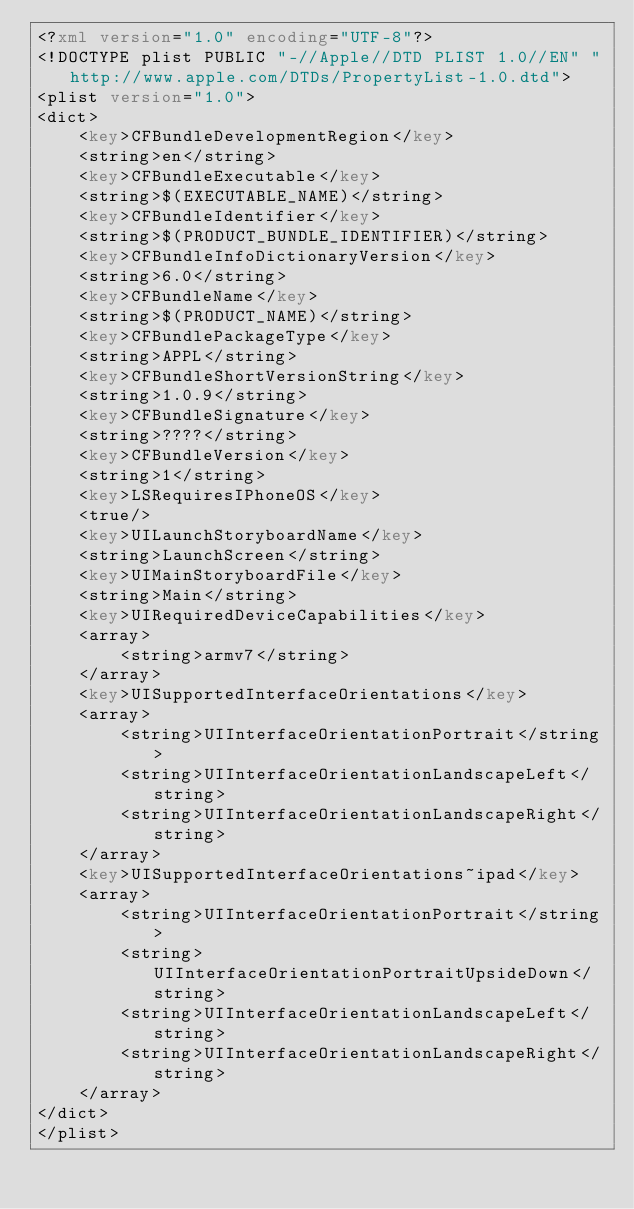Convert code to text. <code><loc_0><loc_0><loc_500><loc_500><_XML_><?xml version="1.0" encoding="UTF-8"?>
<!DOCTYPE plist PUBLIC "-//Apple//DTD PLIST 1.0//EN" "http://www.apple.com/DTDs/PropertyList-1.0.dtd">
<plist version="1.0">
<dict>
	<key>CFBundleDevelopmentRegion</key>
	<string>en</string>
	<key>CFBundleExecutable</key>
	<string>$(EXECUTABLE_NAME)</string>
	<key>CFBundleIdentifier</key>
	<string>$(PRODUCT_BUNDLE_IDENTIFIER)</string>
	<key>CFBundleInfoDictionaryVersion</key>
	<string>6.0</string>
	<key>CFBundleName</key>
	<string>$(PRODUCT_NAME)</string>
	<key>CFBundlePackageType</key>
	<string>APPL</string>
	<key>CFBundleShortVersionString</key>
	<string>1.0.9</string>
	<key>CFBundleSignature</key>
	<string>????</string>
	<key>CFBundleVersion</key>
	<string>1</string>
	<key>LSRequiresIPhoneOS</key>
	<true/>
	<key>UILaunchStoryboardName</key>
	<string>LaunchScreen</string>
	<key>UIMainStoryboardFile</key>
	<string>Main</string>
	<key>UIRequiredDeviceCapabilities</key>
	<array>
		<string>armv7</string>
	</array>
	<key>UISupportedInterfaceOrientations</key>
	<array>
		<string>UIInterfaceOrientationPortrait</string>
		<string>UIInterfaceOrientationLandscapeLeft</string>
		<string>UIInterfaceOrientationLandscapeRight</string>
	</array>
	<key>UISupportedInterfaceOrientations~ipad</key>
	<array>
		<string>UIInterfaceOrientationPortrait</string>
		<string>UIInterfaceOrientationPortraitUpsideDown</string>
		<string>UIInterfaceOrientationLandscapeLeft</string>
		<string>UIInterfaceOrientationLandscapeRight</string>
	</array>
</dict>
</plist>
</code> 